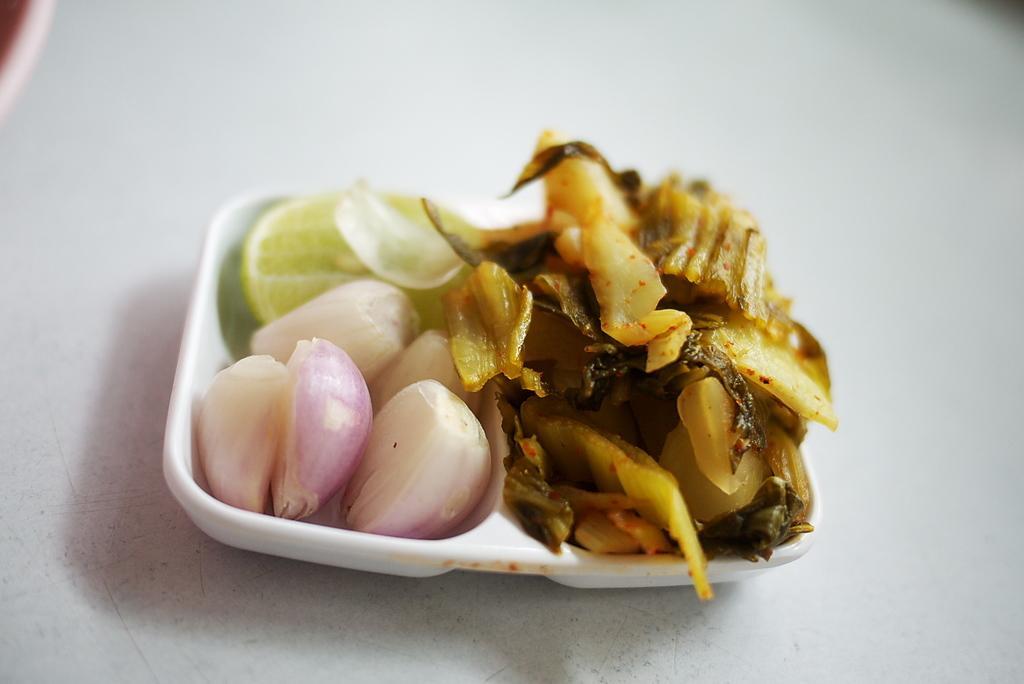Could you give a brief overview of what you see in this image? In this picture we can see a table. On the table we can see a bowl which contains lemon slices, onions and food. 